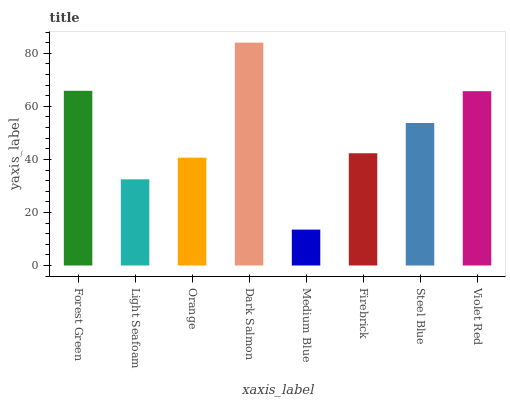Is Medium Blue the minimum?
Answer yes or no. Yes. Is Dark Salmon the maximum?
Answer yes or no. Yes. Is Light Seafoam the minimum?
Answer yes or no. No. Is Light Seafoam the maximum?
Answer yes or no. No. Is Forest Green greater than Light Seafoam?
Answer yes or no. Yes. Is Light Seafoam less than Forest Green?
Answer yes or no. Yes. Is Light Seafoam greater than Forest Green?
Answer yes or no. No. Is Forest Green less than Light Seafoam?
Answer yes or no. No. Is Steel Blue the high median?
Answer yes or no. Yes. Is Firebrick the low median?
Answer yes or no. Yes. Is Violet Red the high median?
Answer yes or no. No. Is Light Seafoam the low median?
Answer yes or no. No. 